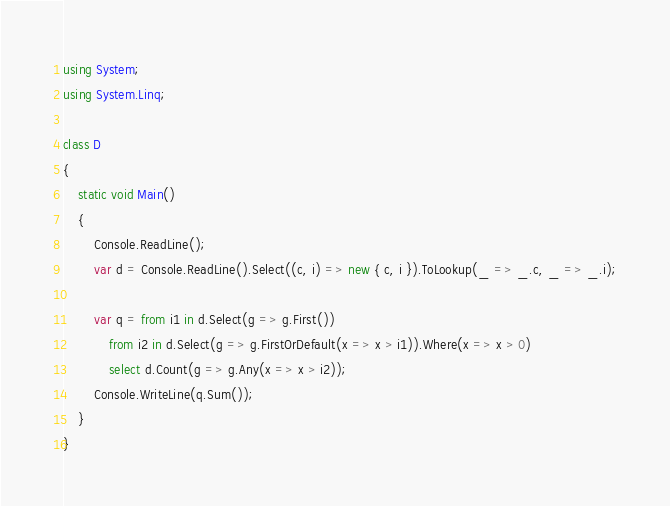<code> <loc_0><loc_0><loc_500><loc_500><_C#_>using System;
using System.Linq;

class D
{
	static void Main()
	{
		Console.ReadLine();
		var d = Console.ReadLine().Select((c, i) => new { c, i }).ToLookup(_ => _.c, _ => _.i);

		var q = from i1 in d.Select(g => g.First())
			from i2 in d.Select(g => g.FirstOrDefault(x => x > i1)).Where(x => x > 0)
			select d.Count(g => g.Any(x => x > i2));
		Console.WriteLine(q.Sum());
	}
}
</code> 